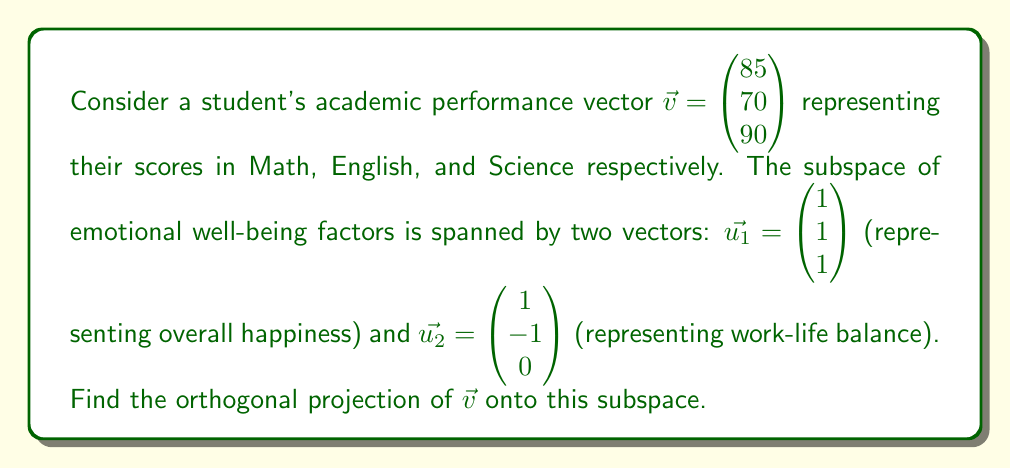Give your solution to this math problem. To find the orthogonal projection, we'll follow these steps:

1) First, we need to find an orthonormal basis for the subspace. We'll use the Gram-Schmidt process:
   $\vec{e_1} = \frac{\vec{u_1}}{\|\vec{u_1}\|} = \frac{1}{\sqrt{3}}\begin{pmatrix} 1 \\ 1 \\ 1 \end{pmatrix}$
   $\vec{e_2} = \vec{u_2} - (\vec{u_2} \cdot \vec{e_1})\vec{e_1} = \begin{pmatrix} 1 \\ -1 \\ 0 \end{pmatrix} - 0\vec{e_1} = \begin{pmatrix} 1 \\ -1 \\ 0 \end{pmatrix}$
   Normalizing $\vec{e_2}$: $\vec{e_2} = \frac{1}{\sqrt{2}}\begin{pmatrix} 1 \\ -1 \\ 0 \end{pmatrix}$

2) Now, we can project $\vec{v}$ onto this orthonormal basis:
   $\text{proj}_W\vec{v} = (\vec{v} \cdot \vec{e_1})\vec{e_1} + (\vec{v} \cdot \vec{e_2})\vec{e_2}$

3) Calculate the dot products:
   $\vec{v} \cdot \vec{e_1} = \frac{1}{\sqrt{3}}(85 + 70 + 90) = \frac{245}{\sqrt{3}}$
   $\vec{v} \cdot \vec{e_2} = \frac{1}{\sqrt{2}}(85 - 70) = \frac{15}{\sqrt{2}}$

4) Substitute into the projection formula:
   $\text{proj}_W\vec{v} = \frac{245}{\sqrt{3}} \cdot \frac{1}{\sqrt{3}}\begin{pmatrix} 1 \\ 1 \\ 1 \end{pmatrix} + \frac{15}{\sqrt{2}} \cdot \frac{1}{\sqrt{2}}\begin{pmatrix} 1 \\ -1 \\ 0 \end{pmatrix}$

5) Simplify:
   $\text{proj}_W\vec{v} = \frac{245}{3}\begin{pmatrix} 1 \\ 1 \\ 1 \end{pmatrix} + \frac{15}{2}\begin{pmatrix} 1 \\ -1 \\ 0 \end{pmatrix}$

6) Calculate the final result:
   $\text{proj}_W\vec{v} = \begin{pmatrix} 245/3 + 15/2 \\ 245/3 - 15/2 \\ 245/3 \end{pmatrix} = \begin{pmatrix} 89.58 \\ 74.08 \\ 81.67 \end{pmatrix}$
Answer: $$\text{proj}_W\vec{v} = \begin{pmatrix} 89.58 \\ 74.08 \\ 81.67 \end{pmatrix}$$ 